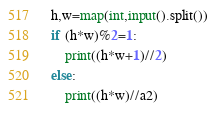Convert code to text. <code><loc_0><loc_0><loc_500><loc_500><_Python_>h,w=map(int,input().split())
if (h*w)%2=1:
    print((h*w+1)//2)
else:
    print((h*w)//a2)</code> 